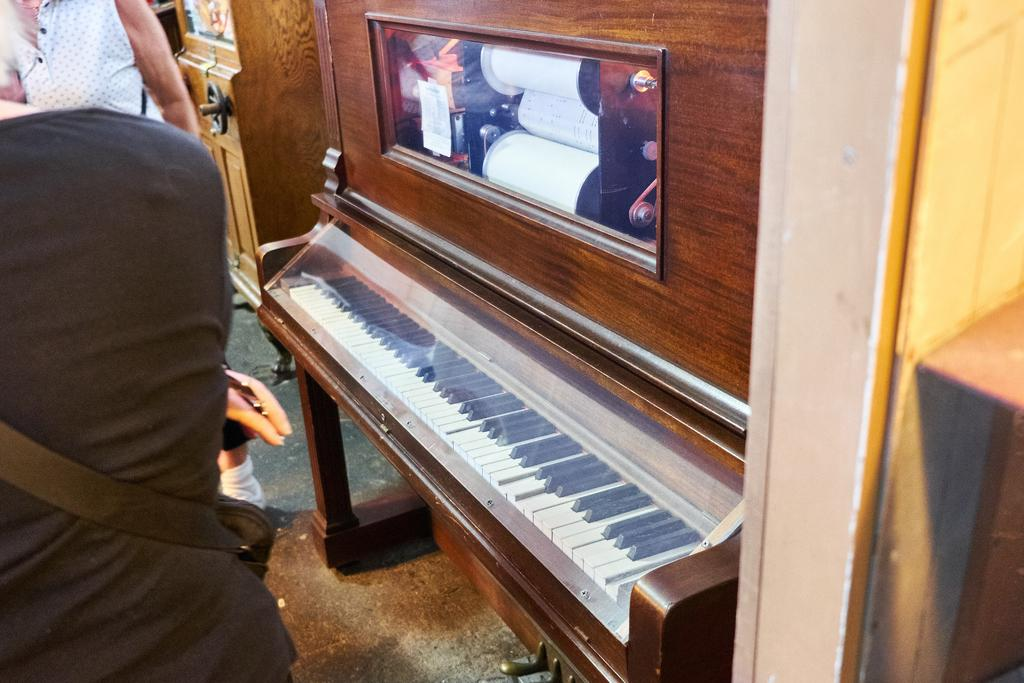What is the main object in the center of the image? There is a piano in the center of the image. Are there any additional features on the piano? Yes, there is a frame attached to the piano. What is happening in the left corner of the image? There are persons moving around in the left corner of the image. What type of sack can be seen being used as a key in the image? There is no sack or key present in the image; it features a piano with a frame and persons moving around in the left corner. 